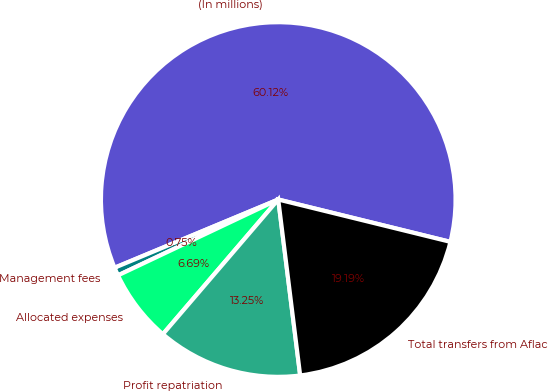Convert chart. <chart><loc_0><loc_0><loc_500><loc_500><pie_chart><fcel>(In millions)<fcel>Management fees<fcel>Allocated expenses<fcel>Profit repatriation<fcel>Total transfers from Aflac<nl><fcel>60.13%<fcel>0.75%<fcel>6.69%<fcel>13.25%<fcel>19.19%<nl></chart> 